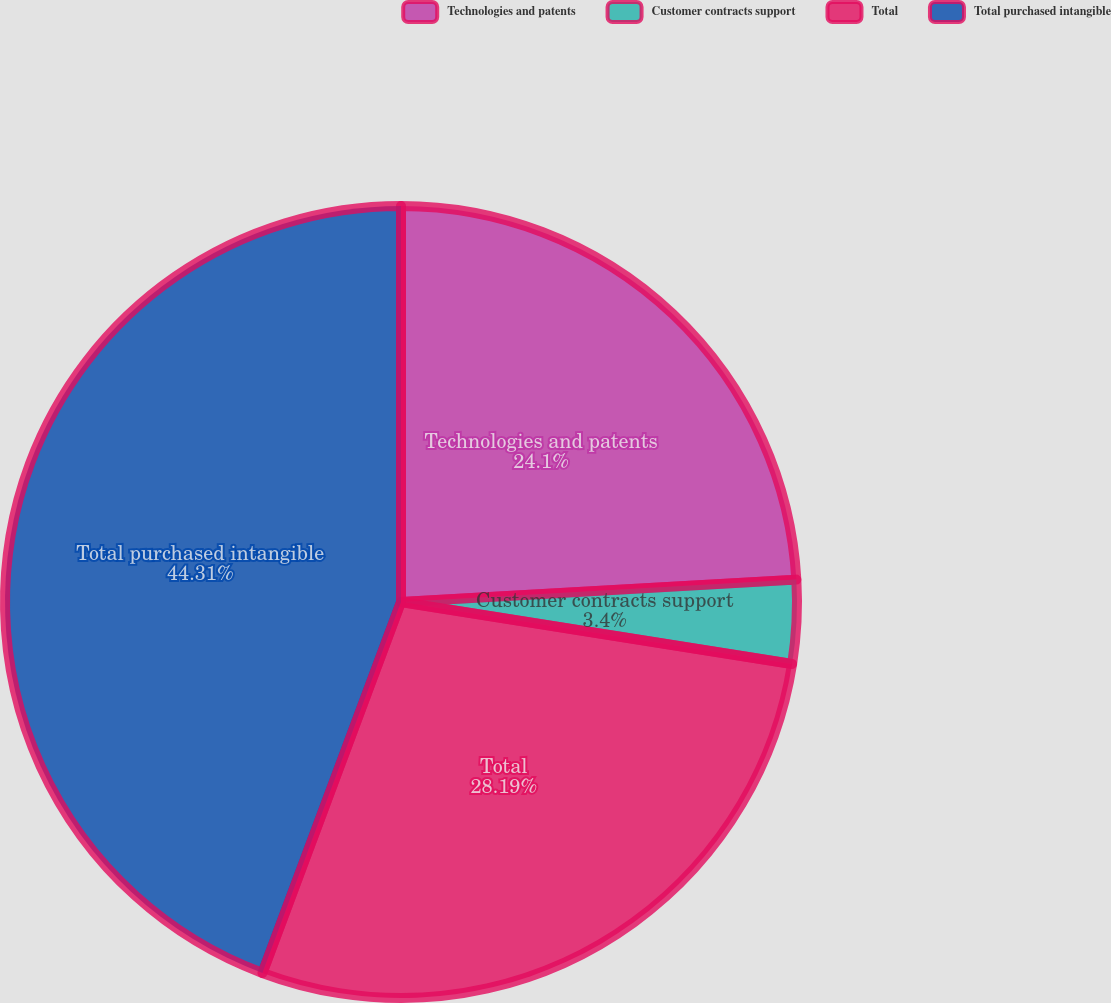<chart> <loc_0><loc_0><loc_500><loc_500><pie_chart><fcel>Technologies and patents<fcel>Customer contracts support<fcel>Total<fcel>Total purchased intangible<nl><fcel>24.1%<fcel>3.4%<fcel>28.19%<fcel>44.31%<nl></chart> 